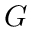<formula> <loc_0><loc_0><loc_500><loc_500>G</formula> 